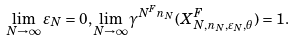<formula> <loc_0><loc_0><loc_500><loc_500>\lim _ { N \to \infty } \varepsilon _ { N } = 0 , \lim _ { N \to \infty } \gamma ^ { N ^ { F } n _ { N } } ( X ^ { F } _ { N , n _ { N } , \varepsilon _ { N } , \theta } ) = 1 .</formula> 